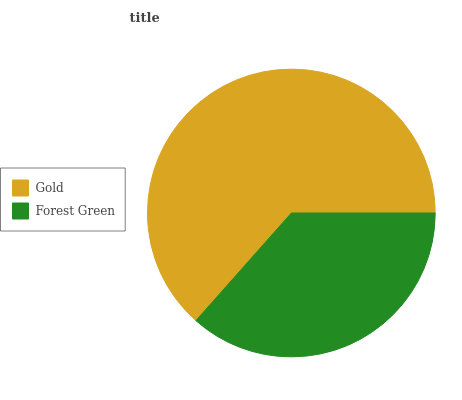Is Forest Green the minimum?
Answer yes or no. Yes. Is Gold the maximum?
Answer yes or no. Yes. Is Forest Green the maximum?
Answer yes or no. No. Is Gold greater than Forest Green?
Answer yes or no. Yes. Is Forest Green less than Gold?
Answer yes or no. Yes. Is Forest Green greater than Gold?
Answer yes or no. No. Is Gold less than Forest Green?
Answer yes or no. No. Is Gold the high median?
Answer yes or no. Yes. Is Forest Green the low median?
Answer yes or no. Yes. Is Forest Green the high median?
Answer yes or no. No. Is Gold the low median?
Answer yes or no. No. 